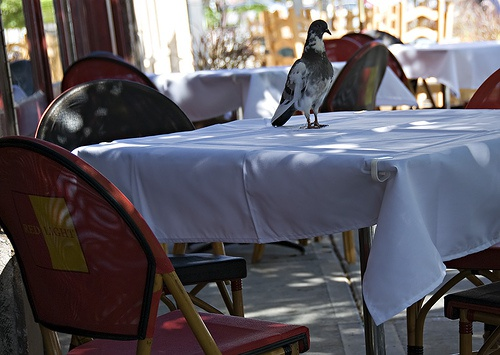Describe the objects in this image and their specific colors. I can see dining table in gray and darkgray tones, chair in gray, black, maroon, and purple tones, chair in gray, black, darkgray, and lightgray tones, chair in gray, black, and darkgray tones, and bird in gray and black tones in this image. 